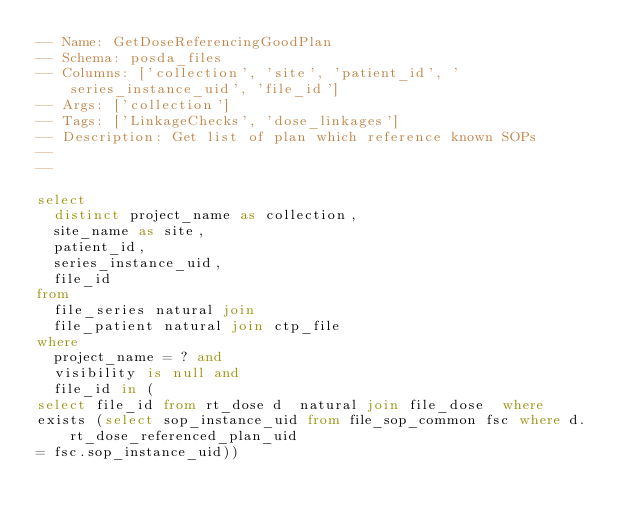<code> <loc_0><loc_0><loc_500><loc_500><_SQL_>-- Name: GetDoseReferencingGoodPlan
-- Schema: posda_files
-- Columns: ['collection', 'site', 'patient_id', 'series_instance_uid', 'file_id']
-- Args: ['collection']
-- Tags: ['LinkageChecks', 'dose_linkages']
-- Description: Get list of plan which reference known SOPs
-- 
-- 

select
  distinct project_name as collection,
  site_name as site,
  patient_id,
  series_instance_uid,
  file_id
from
  file_series natural join
  file_patient natural join ctp_file
where
  project_name = ? and
  visibility is null and
  file_id in (
select file_id from rt_dose d  natural join file_dose  where
exists (select sop_instance_uid from file_sop_common fsc where d.rt_dose_referenced_plan_uid
= fsc.sop_instance_uid))</code> 